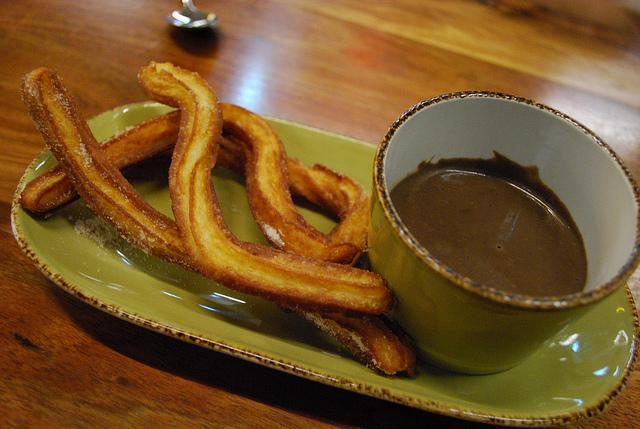How many containers are white?
Give a very brief answer. 0. 